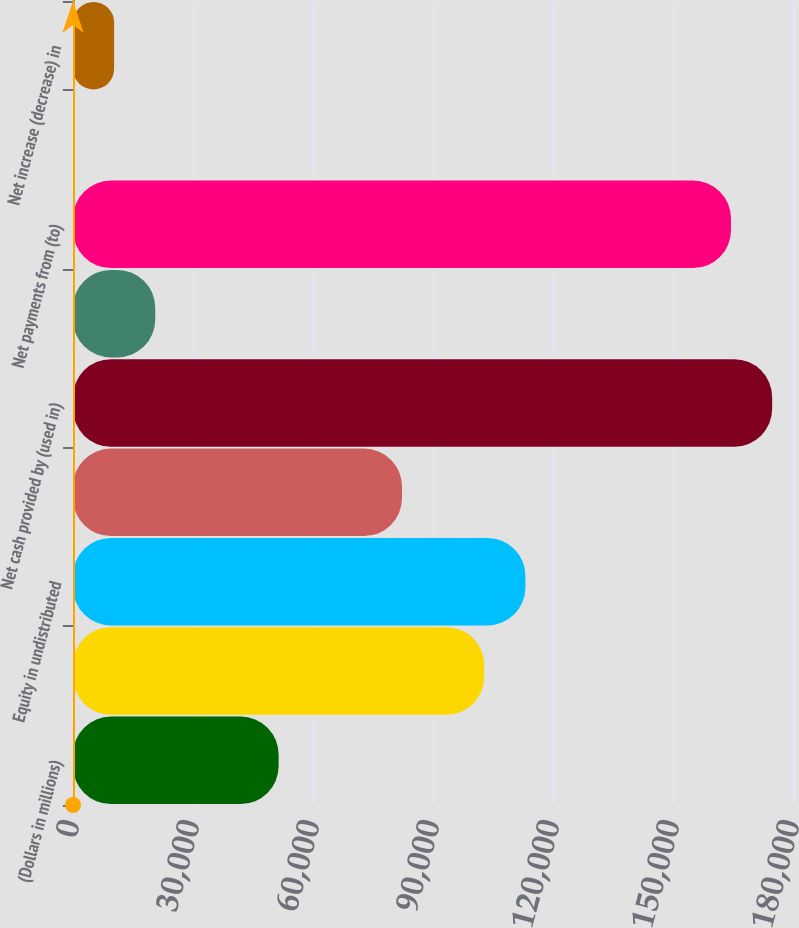<chart> <loc_0><loc_0><loc_500><loc_500><bar_chart><fcel>(Dollars in millions)<fcel>Net income<fcel>Equity in undistributed<fcel>Other operating activities net<fcel>Net cash provided by (used in)<fcel>Net sales (purchases) of<fcel>Net payments from (to)<fcel>Other investing activities net<fcel>Net increase (decrease) in<nl><fcel>51410.5<fcel>102818<fcel>113100<fcel>82255<fcel>174788<fcel>20566<fcel>164507<fcel>3<fcel>10284.5<nl></chart> 